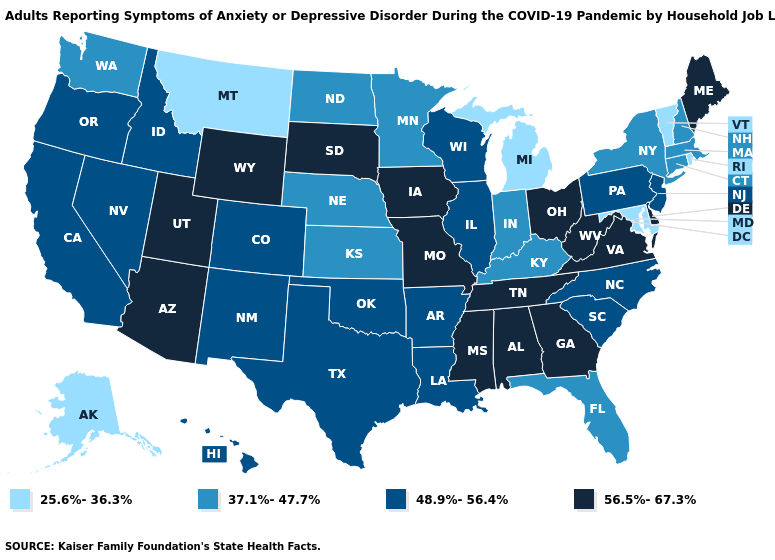Which states hav the highest value in the West?
Quick response, please. Arizona, Utah, Wyoming. What is the value of California?
Keep it brief. 48.9%-56.4%. Among the states that border Tennessee , which have the highest value?
Concise answer only. Alabama, Georgia, Mississippi, Missouri, Virginia. Does Nevada have the lowest value in the West?
Quick response, please. No. Does Louisiana have a lower value than Utah?
Concise answer only. Yes. What is the value of Illinois?
Keep it brief. 48.9%-56.4%. Which states have the lowest value in the West?
Quick response, please. Alaska, Montana. How many symbols are there in the legend?
Answer briefly. 4. What is the value of Missouri?
Answer briefly. 56.5%-67.3%. Name the states that have a value in the range 37.1%-47.7%?
Quick response, please. Connecticut, Florida, Indiana, Kansas, Kentucky, Massachusetts, Minnesota, Nebraska, New Hampshire, New York, North Dakota, Washington. Which states have the lowest value in the USA?
Concise answer only. Alaska, Maryland, Michigan, Montana, Rhode Island, Vermont. What is the highest value in the USA?
Short answer required. 56.5%-67.3%. Name the states that have a value in the range 56.5%-67.3%?
Answer briefly. Alabama, Arizona, Delaware, Georgia, Iowa, Maine, Mississippi, Missouri, Ohio, South Dakota, Tennessee, Utah, Virginia, West Virginia, Wyoming. Which states have the highest value in the USA?
Concise answer only. Alabama, Arizona, Delaware, Georgia, Iowa, Maine, Mississippi, Missouri, Ohio, South Dakota, Tennessee, Utah, Virginia, West Virginia, Wyoming. What is the value of Maine?
Keep it brief. 56.5%-67.3%. 